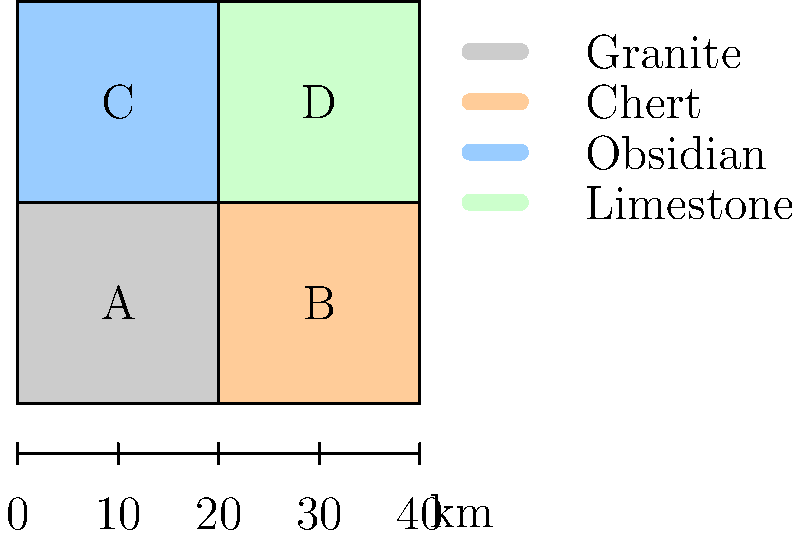Based on the geological resource map provided, which region would be most suitable for finding materials used in creating sharp cutting tools by ancient human settlements? To determine the most suitable region for finding materials used in creating sharp cutting tools, we need to consider the properties of the geological resources shown on the map:

1. Granite (Region A): While durable, granite is not ideal for creating sharp cutting tools due to its coarse-grained structure.

2. Chert (Region B): Chert is an excellent material for making sharp cutting tools. It is a fine-grained sedimentary rock that can be easily flaked to create sharp edges.

3. Obsidian (Region C): Obsidian is a volcanic glass that can be worked into extremely sharp cutting tools. It was highly prized by ancient cultures for its ability to produce razor-sharp edges.

4. Limestone (Region D): Limestone is generally too soft and not suitable for creating durable cutting tools.

Among these materials, both chert and obsidian are excellent choices for creating sharp cutting tools. However, obsidian typically produces sharper edges and was often preferred by ancient cultures when available.

Therefore, Region C, containing obsidian, would be the most suitable area for finding materials used in creating sharp cutting tools by ancient human settlements.
Answer: Region C (Obsidian) 